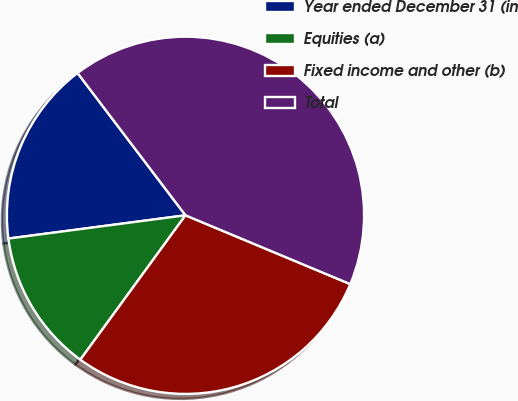Convert chart to OTSL. <chart><loc_0><loc_0><loc_500><loc_500><pie_chart><fcel>Year ended December 31 (in<fcel>Equities (a)<fcel>Fixed income and other (b)<fcel>Total<nl><fcel>16.75%<fcel>12.9%<fcel>28.72%<fcel>41.62%<nl></chart> 